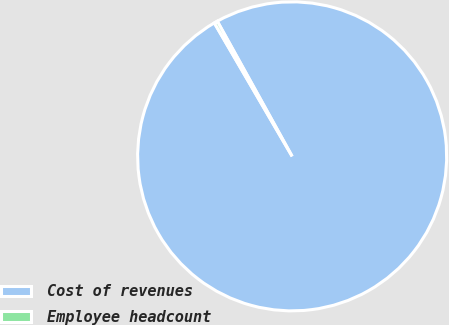Convert chart to OTSL. <chart><loc_0><loc_0><loc_500><loc_500><pie_chart><fcel>Cost of revenues<fcel>Employee headcount<nl><fcel>99.65%<fcel>0.35%<nl></chart> 